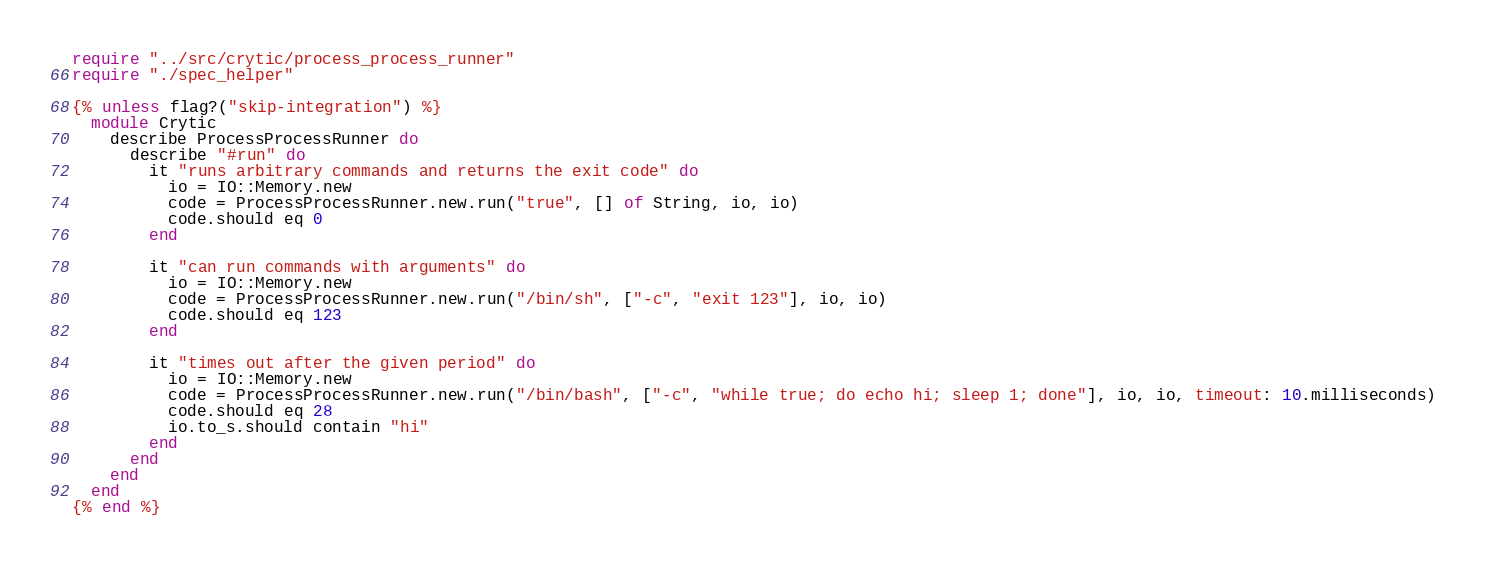<code> <loc_0><loc_0><loc_500><loc_500><_Crystal_>require "../src/crytic/process_process_runner"
require "./spec_helper"

{% unless flag?("skip-integration") %}
  module Crytic
    describe ProcessProcessRunner do
      describe "#run" do
        it "runs arbitrary commands and returns the exit code" do
          io = IO::Memory.new
          code = ProcessProcessRunner.new.run("true", [] of String, io, io)
          code.should eq 0
        end

        it "can run commands with arguments" do
          io = IO::Memory.new
          code = ProcessProcessRunner.new.run("/bin/sh", ["-c", "exit 123"], io, io)
          code.should eq 123
        end

        it "times out after the given period" do
          io = IO::Memory.new
          code = ProcessProcessRunner.new.run("/bin/bash", ["-c", "while true; do echo hi; sleep 1; done"], io, io, timeout: 10.milliseconds)
          code.should eq 28
          io.to_s.should contain "hi"
        end
      end
    end
  end
{% end %}
</code> 